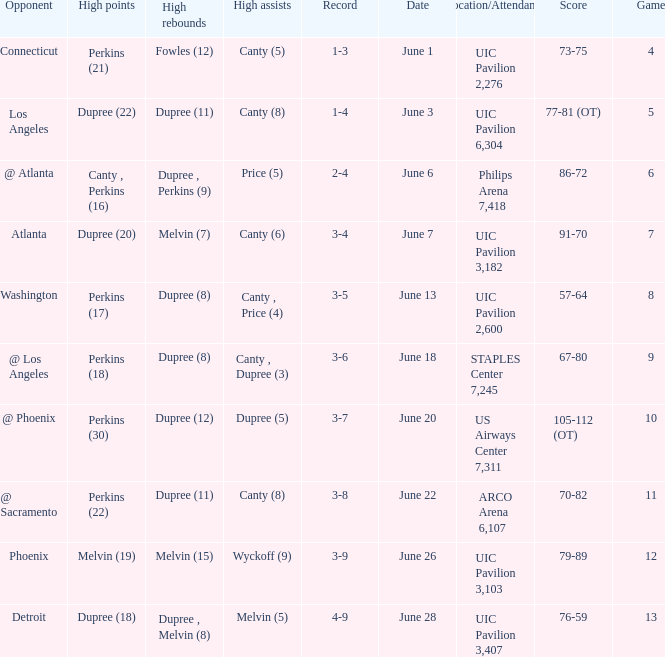Would you be able to parse every entry in this table? {'header': ['Opponent', 'High points', 'High rebounds', 'High assists', 'Record', 'Date', 'Location/Attendance', 'Score', 'Game'], 'rows': [['Connecticut', 'Perkins (21)', 'Fowles (12)', 'Canty (5)', '1-3', 'June 1', 'UIC Pavilion 2,276', '73-75', '4'], ['Los Angeles', 'Dupree (22)', 'Dupree (11)', 'Canty (8)', '1-4', 'June 3', 'UIC Pavilion 6,304', '77-81 (OT)', '5'], ['@ Atlanta', 'Canty , Perkins (16)', 'Dupree , Perkins (9)', 'Price (5)', '2-4', 'June 6', 'Philips Arena 7,418', '86-72', '6'], ['Atlanta', 'Dupree (20)', 'Melvin (7)', 'Canty (6)', '3-4', 'June 7', 'UIC Pavilion 3,182', '91-70', '7'], ['Washington', 'Perkins (17)', 'Dupree (8)', 'Canty , Price (4)', '3-5', 'June 13', 'UIC Pavilion 2,600', '57-64', '8'], ['@ Los Angeles', 'Perkins (18)', 'Dupree (8)', 'Canty , Dupree (3)', '3-6', 'June 18', 'STAPLES Center 7,245', '67-80', '9'], ['@ Phoenix', 'Perkins (30)', 'Dupree (12)', 'Dupree (5)', '3-7', 'June 20', 'US Airways Center 7,311', '105-112 (OT)', '10'], ['@ Sacramento', 'Perkins (22)', 'Dupree (11)', 'Canty (8)', '3-8', 'June 22', 'ARCO Arena 6,107', '70-82', '11'], ['Phoenix', 'Melvin (19)', 'Melvin (15)', 'Wyckoff (9)', '3-9', 'June 26', 'UIC Pavilion 3,103', '79-89', '12'], ['Detroit', 'Dupree (18)', 'Dupree , Melvin (8)', 'Melvin (5)', '4-9', 'June 28', 'UIC Pavilion 3,407', '76-59', '13']]} Who had the most assists in the game that led to a 3-7 record? Dupree (5). 